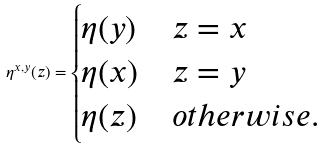Convert formula to latex. <formula><loc_0><loc_0><loc_500><loc_500>\eta ^ { x , y } ( z ) = \begin{cases} \eta ( y ) & z = x \\ \eta ( x ) & z = y \\ \eta ( z ) & o t h e r w i s e . \end{cases}</formula> 